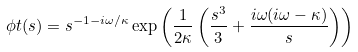Convert formula to latex. <formula><loc_0><loc_0><loc_500><loc_500>\phi t ( s ) = s ^ { - 1 - i \omega / \kappa } \exp \left ( \frac { 1 } { 2 \kappa } \left ( \frac { s ^ { 3 } } { 3 } + \frac { i \omega ( i \omega - \kappa ) } { s } \right ) \right )</formula> 